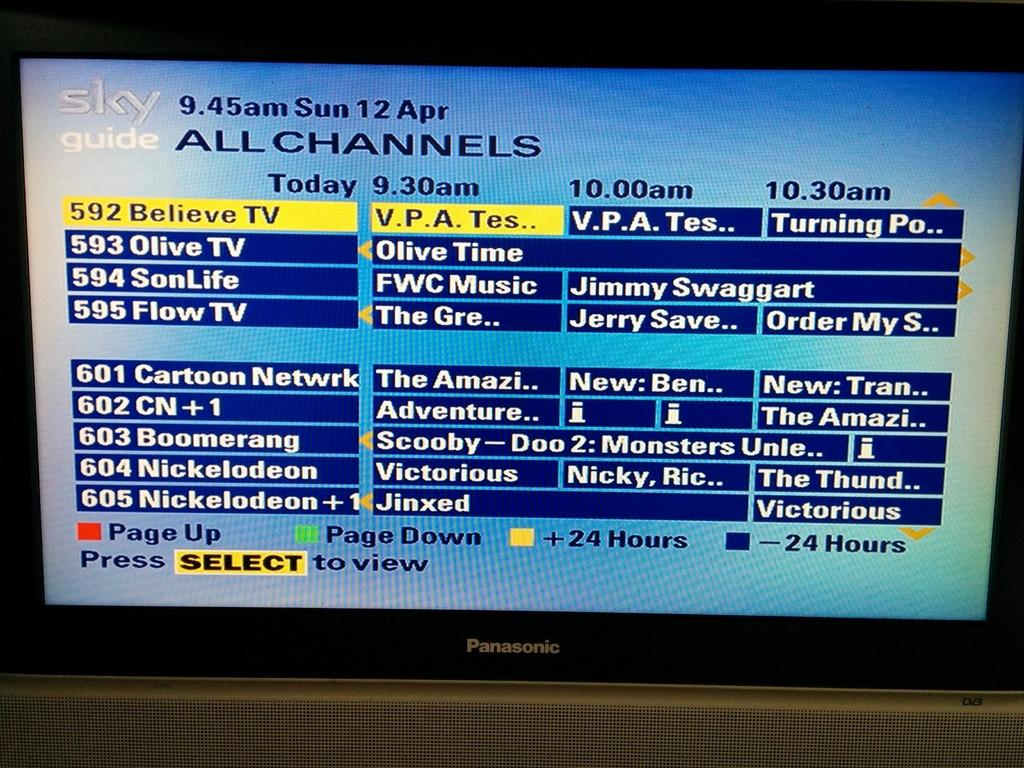Provide a one-sentence caption for the provided image. A Panasonic screen with Sky channels and information. 